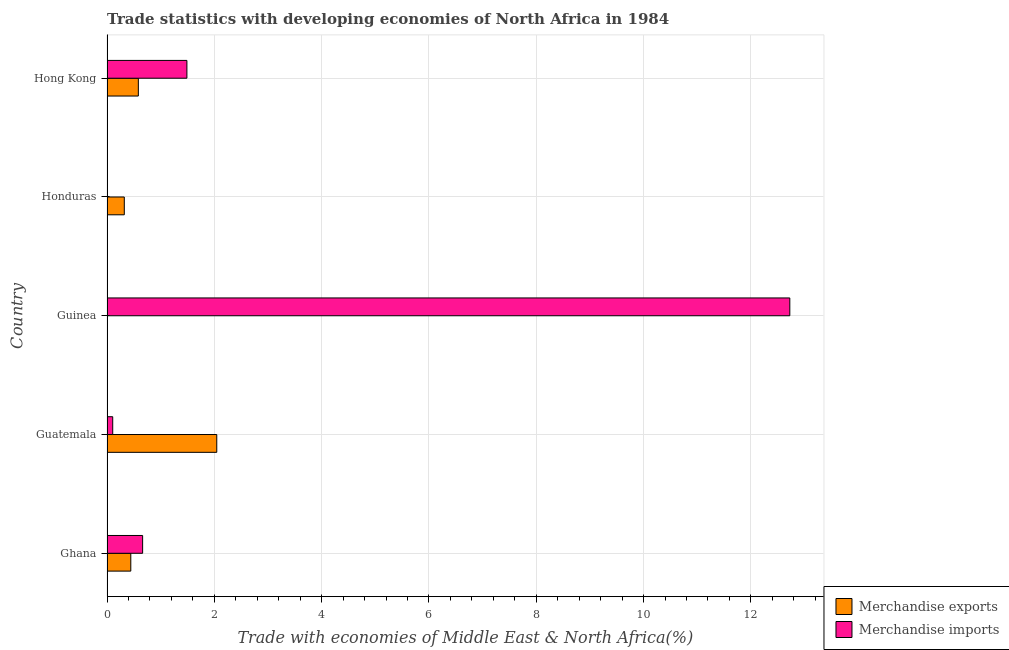How many groups of bars are there?
Make the answer very short. 5. Are the number of bars per tick equal to the number of legend labels?
Provide a succinct answer. Yes. Are the number of bars on each tick of the Y-axis equal?
Your response must be concise. Yes. What is the label of the 1st group of bars from the top?
Offer a terse response. Hong Kong. In how many cases, is the number of bars for a given country not equal to the number of legend labels?
Offer a very short reply. 0. What is the merchandise exports in Honduras?
Provide a short and direct response. 0.32. Across all countries, what is the maximum merchandise imports?
Give a very brief answer. 12.73. Across all countries, what is the minimum merchandise imports?
Offer a terse response. 0. In which country was the merchandise exports maximum?
Your answer should be compact. Guatemala. In which country was the merchandise imports minimum?
Your answer should be very brief. Honduras. What is the total merchandise exports in the graph?
Ensure brevity in your answer.  3.4. What is the difference between the merchandise imports in Guinea and that in Hong Kong?
Offer a terse response. 11.24. What is the difference between the merchandise imports in Honduras and the merchandise exports in Hong Kong?
Keep it short and to the point. -0.58. What is the average merchandise exports per country?
Ensure brevity in your answer.  0.68. What is the difference between the merchandise imports and merchandise exports in Guinea?
Keep it short and to the point. 12.73. In how many countries, is the merchandise imports greater than 12.8 %?
Give a very brief answer. 0. What is the ratio of the merchandise imports in Guatemala to that in Honduras?
Ensure brevity in your answer.  72.82. Is the merchandise exports in Ghana less than that in Guatemala?
Give a very brief answer. Yes. What is the difference between the highest and the second highest merchandise exports?
Your answer should be very brief. 1.46. What is the difference between the highest and the lowest merchandise imports?
Your answer should be compact. 12.72. Is the sum of the merchandise imports in Guatemala and Hong Kong greater than the maximum merchandise exports across all countries?
Offer a very short reply. No. What does the 2nd bar from the top in Guatemala represents?
Offer a very short reply. Merchandise exports. Are all the bars in the graph horizontal?
Provide a succinct answer. Yes. How many countries are there in the graph?
Make the answer very short. 5. What is the difference between two consecutive major ticks on the X-axis?
Give a very brief answer. 2. Does the graph contain any zero values?
Provide a short and direct response. No. Does the graph contain grids?
Offer a very short reply. Yes. How are the legend labels stacked?
Offer a very short reply. Vertical. What is the title of the graph?
Offer a terse response. Trade statistics with developing economies of North Africa in 1984. What is the label or title of the X-axis?
Ensure brevity in your answer.  Trade with economies of Middle East & North Africa(%). What is the Trade with economies of Middle East & North Africa(%) in Merchandise exports in Ghana?
Your answer should be very brief. 0.44. What is the Trade with economies of Middle East & North Africa(%) of Merchandise imports in Ghana?
Offer a very short reply. 0.66. What is the Trade with economies of Middle East & North Africa(%) in Merchandise exports in Guatemala?
Ensure brevity in your answer.  2.05. What is the Trade with economies of Middle East & North Africa(%) in Merchandise imports in Guatemala?
Give a very brief answer. 0.11. What is the Trade with economies of Middle East & North Africa(%) in Merchandise exports in Guinea?
Your response must be concise. 0. What is the Trade with economies of Middle East & North Africa(%) in Merchandise imports in Guinea?
Your answer should be very brief. 12.73. What is the Trade with economies of Middle East & North Africa(%) in Merchandise exports in Honduras?
Make the answer very short. 0.32. What is the Trade with economies of Middle East & North Africa(%) of Merchandise imports in Honduras?
Your answer should be very brief. 0. What is the Trade with economies of Middle East & North Africa(%) in Merchandise exports in Hong Kong?
Make the answer very short. 0.58. What is the Trade with economies of Middle East & North Africa(%) of Merchandise imports in Hong Kong?
Ensure brevity in your answer.  1.49. Across all countries, what is the maximum Trade with economies of Middle East & North Africa(%) in Merchandise exports?
Your response must be concise. 2.05. Across all countries, what is the maximum Trade with economies of Middle East & North Africa(%) of Merchandise imports?
Keep it short and to the point. 12.73. Across all countries, what is the minimum Trade with economies of Middle East & North Africa(%) in Merchandise exports?
Offer a terse response. 0. Across all countries, what is the minimum Trade with economies of Middle East & North Africa(%) of Merchandise imports?
Ensure brevity in your answer.  0. What is the total Trade with economies of Middle East & North Africa(%) in Merchandise exports in the graph?
Keep it short and to the point. 3.4. What is the total Trade with economies of Middle East & North Africa(%) in Merchandise imports in the graph?
Ensure brevity in your answer.  14.99. What is the difference between the Trade with economies of Middle East & North Africa(%) of Merchandise exports in Ghana and that in Guatemala?
Your answer should be very brief. -1.6. What is the difference between the Trade with economies of Middle East & North Africa(%) of Merchandise imports in Ghana and that in Guatemala?
Ensure brevity in your answer.  0.56. What is the difference between the Trade with economies of Middle East & North Africa(%) of Merchandise exports in Ghana and that in Guinea?
Your answer should be compact. 0.44. What is the difference between the Trade with economies of Middle East & North Africa(%) of Merchandise imports in Ghana and that in Guinea?
Provide a short and direct response. -12.06. What is the difference between the Trade with economies of Middle East & North Africa(%) of Merchandise exports in Ghana and that in Honduras?
Your answer should be compact. 0.12. What is the difference between the Trade with economies of Middle East & North Africa(%) in Merchandise imports in Ghana and that in Honduras?
Offer a very short reply. 0.66. What is the difference between the Trade with economies of Middle East & North Africa(%) of Merchandise exports in Ghana and that in Hong Kong?
Your response must be concise. -0.14. What is the difference between the Trade with economies of Middle East & North Africa(%) in Merchandise imports in Ghana and that in Hong Kong?
Provide a short and direct response. -0.83. What is the difference between the Trade with economies of Middle East & North Africa(%) of Merchandise exports in Guatemala and that in Guinea?
Offer a terse response. 2.05. What is the difference between the Trade with economies of Middle East & North Africa(%) in Merchandise imports in Guatemala and that in Guinea?
Keep it short and to the point. -12.62. What is the difference between the Trade with economies of Middle East & North Africa(%) in Merchandise exports in Guatemala and that in Honduras?
Provide a succinct answer. 1.72. What is the difference between the Trade with economies of Middle East & North Africa(%) in Merchandise imports in Guatemala and that in Honduras?
Offer a very short reply. 0.1. What is the difference between the Trade with economies of Middle East & North Africa(%) of Merchandise exports in Guatemala and that in Hong Kong?
Give a very brief answer. 1.46. What is the difference between the Trade with economies of Middle East & North Africa(%) of Merchandise imports in Guatemala and that in Hong Kong?
Give a very brief answer. -1.38. What is the difference between the Trade with economies of Middle East & North Africa(%) in Merchandise exports in Guinea and that in Honduras?
Offer a terse response. -0.32. What is the difference between the Trade with economies of Middle East & North Africa(%) of Merchandise imports in Guinea and that in Honduras?
Keep it short and to the point. 12.72. What is the difference between the Trade with economies of Middle East & North Africa(%) of Merchandise exports in Guinea and that in Hong Kong?
Provide a short and direct response. -0.58. What is the difference between the Trade with economies of Middle East & North Africa(%) in Merchandise imports in Guinea and that in Hong Kong?
Offer a very short reply. 11.24. What is the difference between the Trade with economies of Middle East & North Africa(%) of Merchandise exports in Honduras and that in Hong Kong?
Offer a terse response. -0.26. What is the difference between the Trade with economies of Middle East & North Africa(%) in Merchandise imports in Honduras and that in Hong Kong?
Provide a short and direct response. -1.49. What is the difference between the Trade with economies of Middle East & North Africa(%) of Merchandise exports in Ghana and the Trade with economies of Middle East & North Africa(%) of Merchandise imports in Guatemala?
Ensure brevity in your answer.  0.34. What is the difference between the Trade with economies of Middle East & North Africa(%) of Merchandise exports in Ghana and the Trade with economies of Middle East & North Africa(%) of Merchandise imports in Guinea?
Offer a terse response. -12.28. What is the difference between the Trade with economies of Middle East & North Africa(%) in Merchandise exports in Ghana and the Trade with economies of Middle East & North Africa(%) in Merchandise imports in Honduras?
Ensure brevity in your answer.  0.44. What is the difference between the Trade with economies of Middle East & North Africa(%) of Merchandise exports in Ghana and the Trade with economies of Middle East & North Africa(%) of Merchandise imports in Hong Kong?
Provide a short and direct response. -1.05. What is the difference between the Trade with economies of Middle East & North Africa(%) in Merchandise exports in Guatemala and the Trade with economies of Middle East & North Africa(%) in Merchandise imports in Guinea?
Provide a short and direct response. -10.68. What is the difference between the Trade with economies of Middle East & North Africa(%) in Merchandise exports in Guatemala and the Trade with economies of Middle East & North Africa(%) in Merchandise imports in Honduras?
Your answer should be very brief. 2.04. What is the difference between the Trade with economies of Middle East & North Africa(%) in Merchandise exports in Guatemala and the Trade with economies of Middle East & North Africa(%) in Merchandise imports in Hong Kong?
Keep it short and to the point. 0.56. What is the difference between the Trade with economies of Middle East & North Africa(%) in Merchandise exports in Guinea and the Trade with economies of Middle East & North Africa(%) in Merchandise imports in Honduras?
Your answer should be very brief. -0. What is the difference between the Trade with economies of Middle East & North Africa(%) in Merchandise exports in Guinea and the Trade with economies of Middle East & North Africa(%) in Merchandise imports in Hong Kong?
Your answer should be compact. -1.49. What is the difference between the Trade with economies of Middle East & North Africa(%) in Merchandise exports in Honduras and the Trade with economies of Middle East & North Africa(%) in Merchandise imports in Hong Kong?
Keep it short and to the point. -1.17. What is the average Trade with economies of Middle East & North Africa(%) of Merchandise exports per country?
Give a very brief answer. 0.68. What is the average Trade with economies of Middle East & North Africa(%) in Merchandise imports per country?
Your answer should be compact. 3. What is the difference between the Trade with economies of Middle East & North Africa(%) in Merchandise exports and Trade with economies of Middle East & North Africa(%) in Merchandise imports in Ghana?
Your response must be concise. -0.22. What is the difference between the Trade with economies of Middle East & North Africa(%) in Merchandise exports and Trade with economies of Middle East & North Africa(%) in Merchandise imports in Guatemala?
Offer a terse response. 1.94. What is the difference between the Trade with economies of Middle East & North Africa(%) of Merchandise exports and Trade with economies of Middle East & North Africa(%) of Merchandise imports in Guinea?
Make the answer very short. -12.73. What is the difference between the Trade with economies of Middle East & North Africa(%) in Merchandise exports and Trade with economies of Middle East & North Africa(%) in Merchandise imports in Honduras?
Keep it short and to the point. 0.32. What is the difference between the Trade with economies of Middle East & North Africa(%) of Merchandise exports and Trade with economies of Middle East & North Africa(%) of Merchandise imports in Hong Kong?
Give a very brief answer. -0.91. What is the ratio of the Trade with economies of Middle East & North Africa(%) of Merchandise exports in Ghana to that in Guatemala?
Make the answer very short. 0.22. What is the ratio of the Trade with economies of Middle East & North Africa(%) in Merchandise imports in Ghana to that in Guatemala?
Make the answer very short. 6.24. What is the ratio of the Trade with economies of Middle East & North Africa(%) of Merchandise exports in Ghana to that in Guinea?
Provide a short and direct response. 751.75. What is the ratio of the Trade with economies of Middle East & North Africa(%) in Merchandise imports in Ghana to that in Guinea?
Keep it short and to the point. 0.05. What is the ratio of the Trade with economies of Middle East & North Africa(%) in Merchandise exports in Ghana to that in Honduras?
Offer a terse response. 1.37. What is the ratio of the Trade with economies of Middle East & North Africa(%) in Merchandise imports in Ghana to that in Honduras?
Provide a short and direct response. 454.49. What is the ratio of the Trade with economies of Middle East & North Africa(%) in Merchandise exports in Ghana to that in Hong Kong?
Give a very brief answer. 0.76. What is the ratio of the Trade with economies of Middle East & North Africa(%) of Merchandise imports in Ghana to that in Hong Kong?
Your response must be concise. 0.45. What is the ratio of the Trade with economies of Middle East & North Africa(%) of Merchandise exports in Guatemala to that in Guinea?
Make the answer very short. 3469.01. What is the ratio of the Trade with economies of Middle East & North Africa(%) in Merchandise imports in Guatemala to that in Guinea?
Give a very brief answer. 0.01. What is the ratio of the Trade with economies of Middle East & North Africa(%) of Merchandise exports in Guatemala to that in Honduras?
Offer a terse response. 6.34. What is the ratio of the Trade with economies of Middle East & North Africa(%) in Merchandise imports in Guatemala to that in Honduras?
Provide a succinct answer. 72.82. What is the ratio of the Trade with economies of Middle East & North Africa(%) in Merchandise exports in Guatemala to that in Hong Kong?
Give a very brief answer. 3.5. What is the ratio of the Trade with economies of Middle East & North Africa(%) of Merchandise imports in Guatemala to that in Hong Kong?
Keep it short and to the point. 0.07. What is the ratio of the Trade with economies of Middle East & North Africa(%) in Merchandise exports in Guinea to that in Honduras?
Your answer should be compact. 0. What is the ratio of the Trade with economies of Middle East & North Africa(%) in Merchandise imports in Guinea to that in Honduras?
Provide a succinct answer. 8710.8. What is the ratio of the Trade with economies of Middle East & North Africa(%) of Merchandise exports in Guinea to that in Hong Kong?
Keep it short and to the point. 0. What is the ratio of the Trade with economies of Middle East & North Africa(%) in Merchandise imports in Guinea to that in Hong Kong?
Your response must be concise. 8.55. What is the ratio of the Trade with economies of Middle East & North Africa(%) of Merchandise exports in Honduras to that in Hong Kong?
Give a very brief answer. 0.55. What is the difference between the highest and the second highest Trade with economies of Middle East & North Africa(%) of Merchandise exports?
Ensure brevity in your answer.  1.46. What is the difference between the highest and the second highest Trade with economies of Middle East & North Africa(%) in Merchandise imports?
Make the answer very short. 11.24. What is the difference between the highest and the lowest Trade with economies of Middle East & North Africa(%) of Merchandise exports?
Offer a terse response. 2.05. What is the difference between the highest and the lowest Trade with economies of Middle East & North Africa(%) of Merchandise imports?
Make the answer very short. 12.72. 